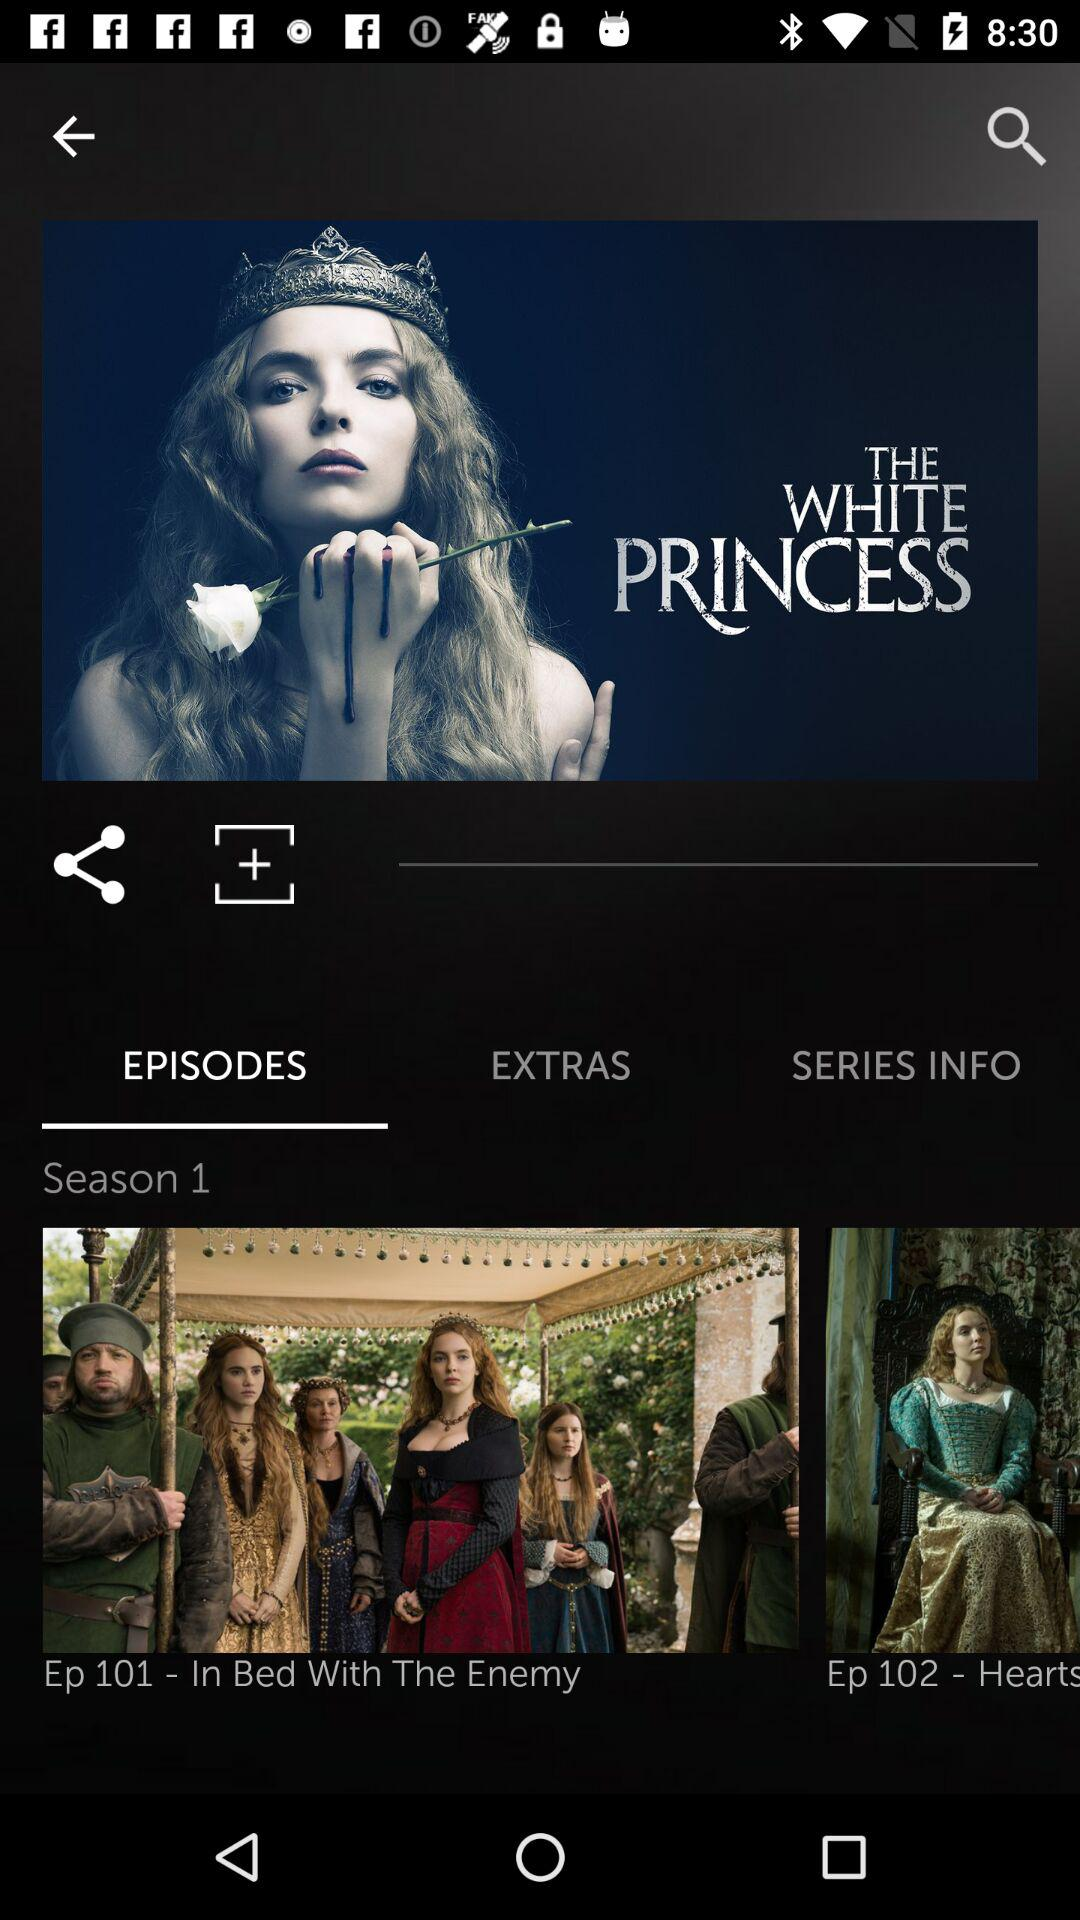What's the name of Episode Number 101? The name of the episode number 101 is In Bed With The Enemy. 